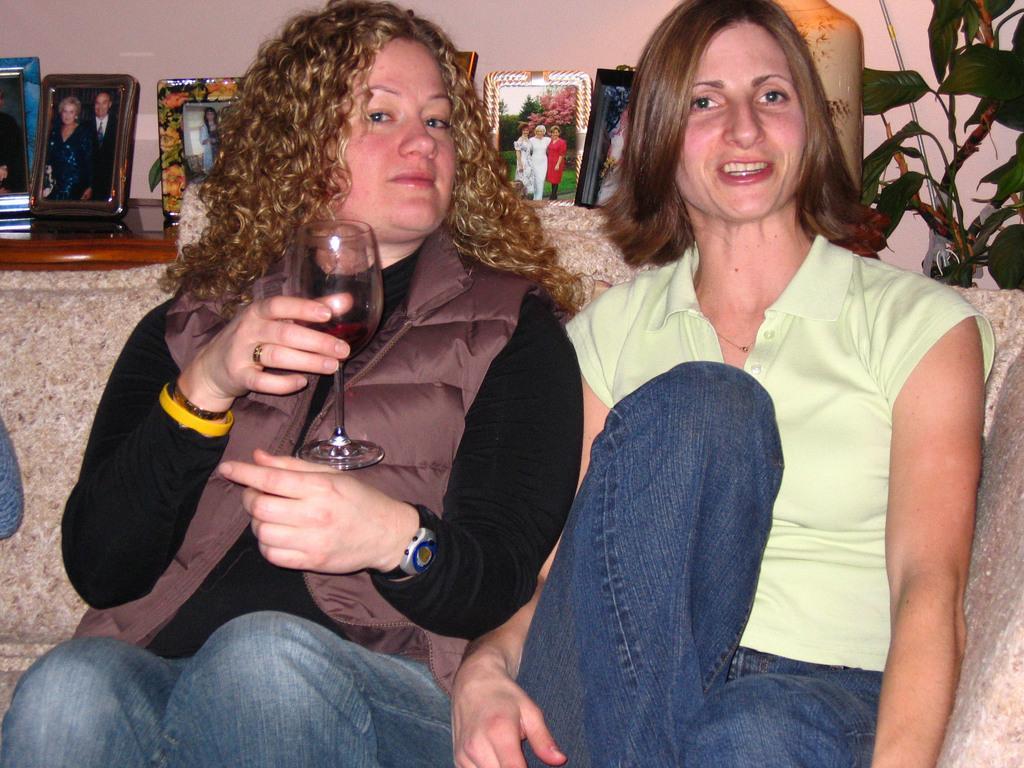Please provide a concise description of this image. In this image we can see this woman is sitting on the sofa while holding a glass in her hand. This woman is also sitting on the sofa. In the background we can see photo frames on table, plants and wall. 